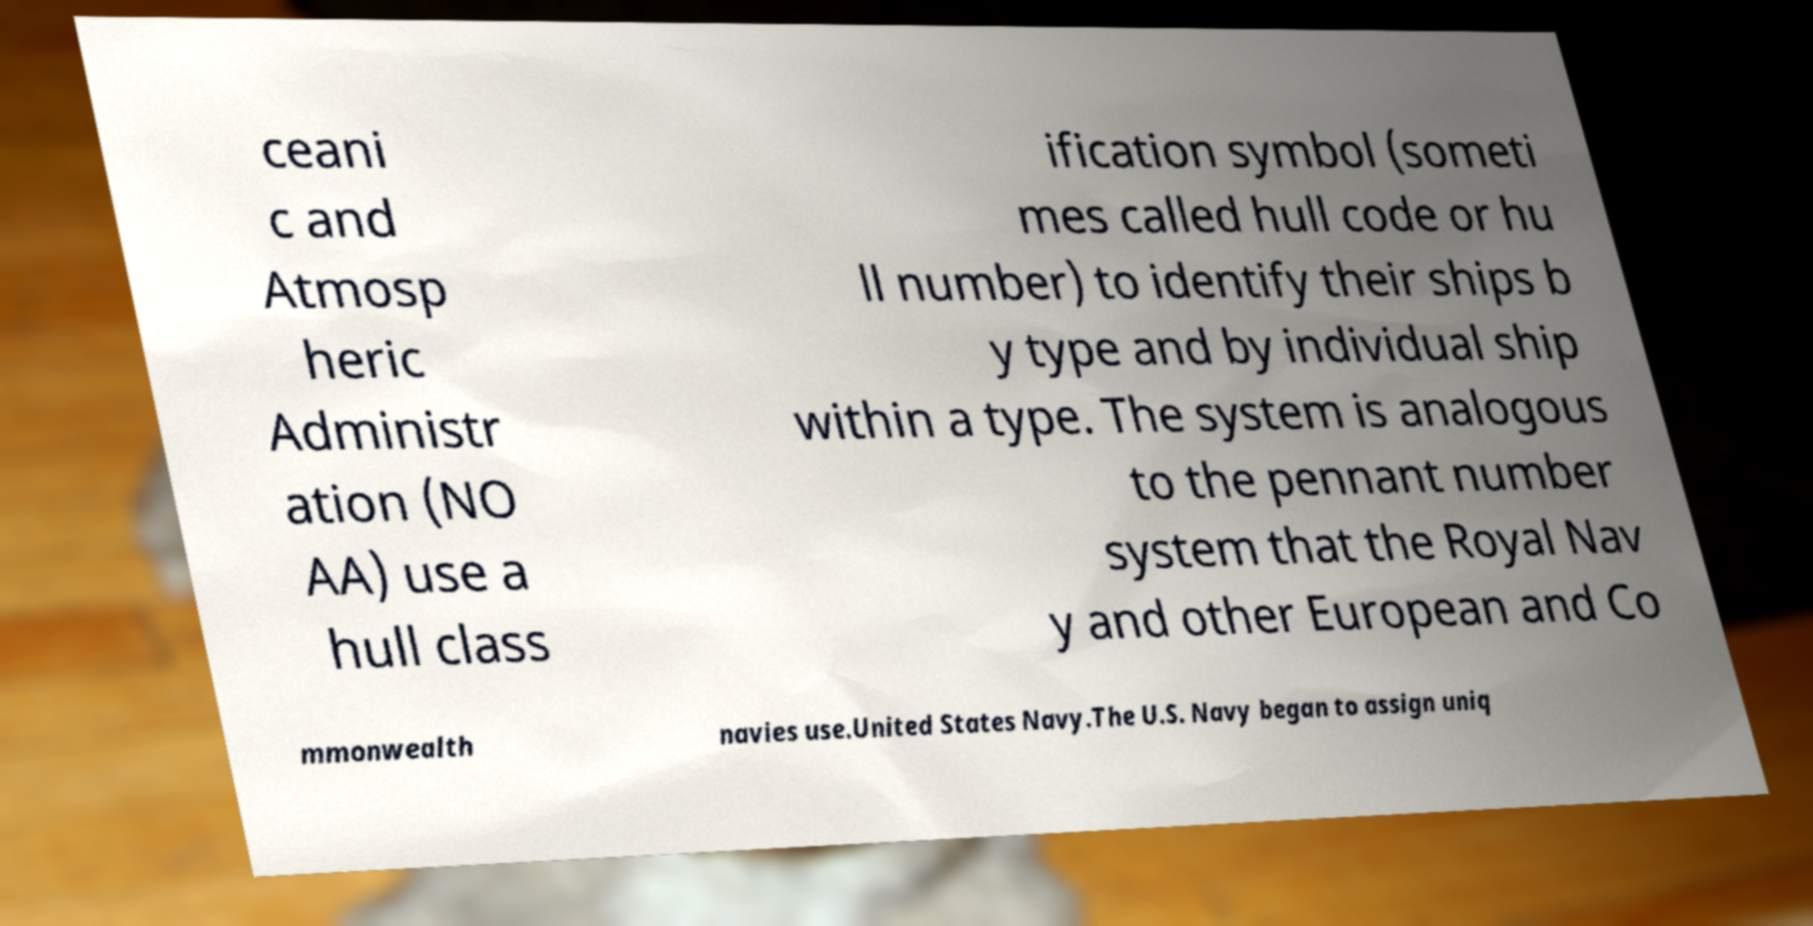I need the written content from this picture converted into text. Can you do that? ceani c and Atmosp heric Administr ation (NO AA) use a hull class ification symbol (someti mes called hull code or hu ll number) to identify their ships b y type and by individual ship within a type. The system is analogous to the pennant number system that the Royal Nav y and other European and Co mmonwealth navies use.United States Navy.The U.S. Navy began to assign uniq 